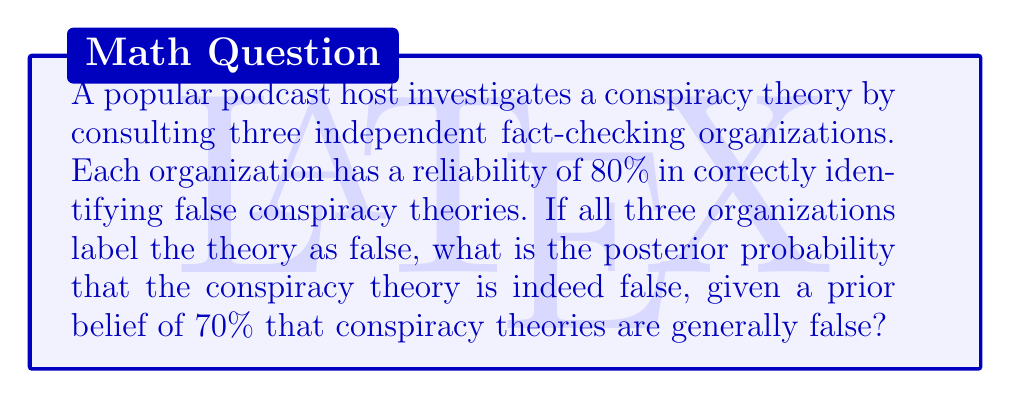Solve this math problem. Let's approach this using Bayes' theorem:

1) Define our events:
   F: The conspiracy theory is false
   E: All three fact-checkers label the theory as false

2) We're given:
   P(F) = 0.70 (prior probability)
   P(E|F) = 0.8 * 0.8 * 0.8 = 0.512 (probability all three correctly identify a false theory)
   P(E|not F) = 0.2 * 0.2 * 0.2 = 0.008 (probability all three incorrectly label a true theory as false)

3) Bayes' theorem states:

   $$P(F|E) = \frac{P(E|F) * P(F)}{P(E)}$$

4) We need to calculate P(E):
   $$P(E) = P(E|F) * P(F) + P(E|not F) * P(not F)$$
   $$P(E) = 0.512 * 0.70 + 0.008 * 0.30 = 0.3586$$

5) Now we can apply Bayes' theorem:

   $$P(F|E) = \frac{0.512 * 0.70}{0.3586} \approx 0.9983$$

6) Convert to a percentage: 0.9983 * 100% ≈ 99.83%
Answer: The posterior probability that the conspiracy theory is false, given that all three fact-checking organizations labeled it as false, is approximately 99.83%. 